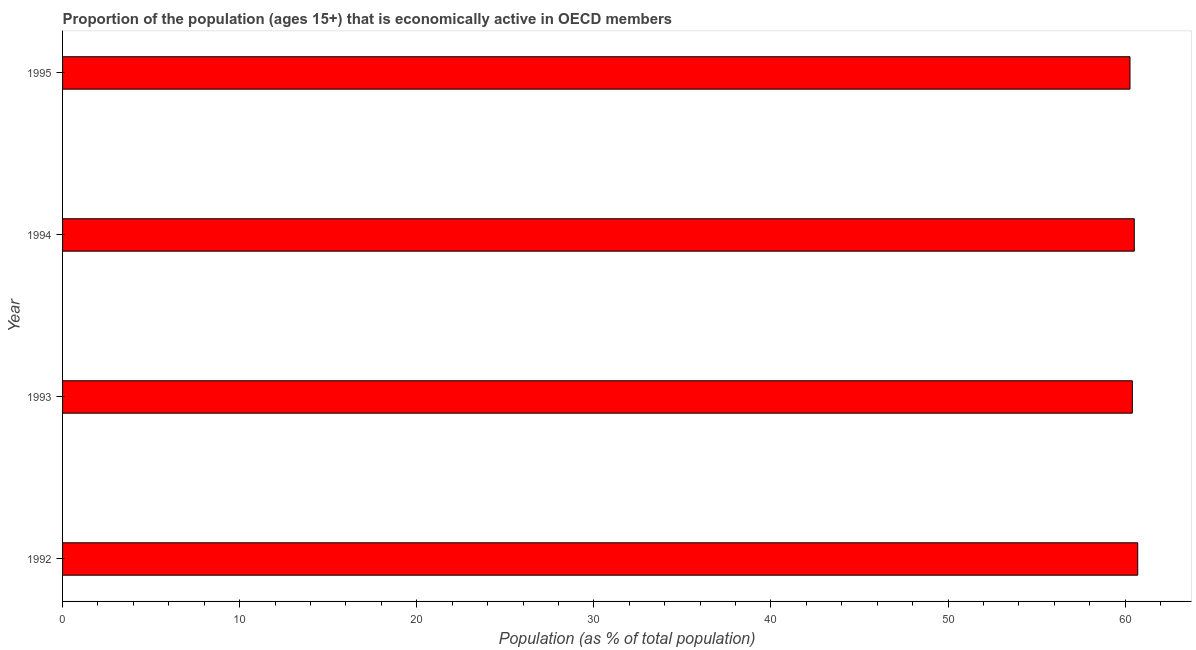Does the graph contain any zero values?
Your answer should be compact. No. What is the title of the graph?
Make the answer very short. Proportion of the population (ages 15+) that is economically active in OECD members. What is the label or title of the X-axis?
Ensure brevity in your answer.  Population (as % of total population). What is the percentage of economically active population in 1993?
Offer a terse response. 60.41. Across all years, what is the maximum percentage of economically active population?
Your answer should be very brief. 60.71. Across all years, what is the minimum percentage of economically active population?
Your answer should be compact. 60.27. What is the sum of the percentage of economically active population?
Provide a short and direct response. 241.9. What is the difference between the percentage of economically active population in 1994 and 1995?
Ensure brevity in your answer.  0.24. What is the average percentage of economically active population per year?
Your answer should be very brief. 60.48. What is the median percentage of economically active population?
Offer a very short reply. 60.46. In how many years, is the percentage of economically active population greater than 48 %?
Make the answer very short. 4. Is the percentage of economically active population in 1992 less than that in 1995?
Offer a terse response. No. Is the difference between the percentage of economically active population in 1992 and 1994 greater than the difference between any two years?
Provide a succinct answer. No. What is the difference between the highest and the second highest percentage of economically active population?
Your response must be concise. 0.2. What is the difference between the highest and the lowest percentage of economically active population?
Provide a succinct answer. 0.44. How many bars are there?
Offer a very short reply. 4. What is the Population (as % of total population) of 1992?
Give a very brief answer. 60.71. What is the Population (as % of total population) of 1993?
Offer a very short reply. 60.41. What is the Population (as % of total population) in 1994?
Ensure brevity in your answer.  60.52. What is the Population (as % of total population) in 1995?
Your response must be concise. 60.27. What is the difference between the Population (as % of total population) in 1992 and 1993?
Keep it short and to the point. 0.31. What is the difference between the Population (as % of total population) in 1992 and 1994?
Provide a short and direct response. 0.2. What is the difference between the Population (as % of total population) in 1992 and 1995?
Offer a very short reply. 0.44. What is the difference between the Population (as % of total population) in 1993 and 1994?
Offer a terse response. -0.11. What is the difference between the Population (as % of total population) in 1993 and 1995?
Ensure brevity in your answer.  0.13. What is the difference between the Population (as % of total population) in 1994 and 1995?
Provide a succinct answer. 0.24. What is the ratio of the Population (as % of total population) in 1992 to that in 1993?
Your answer should be very brief. 1. What is the ratio of the Population (as % of total population) in 1992 to that in 1994?
Give a very brief answer. 1. What is the ratio of the Population (as % of total population) in 1992 to that in 1995?
Provide a short and direct response. 1.01. 